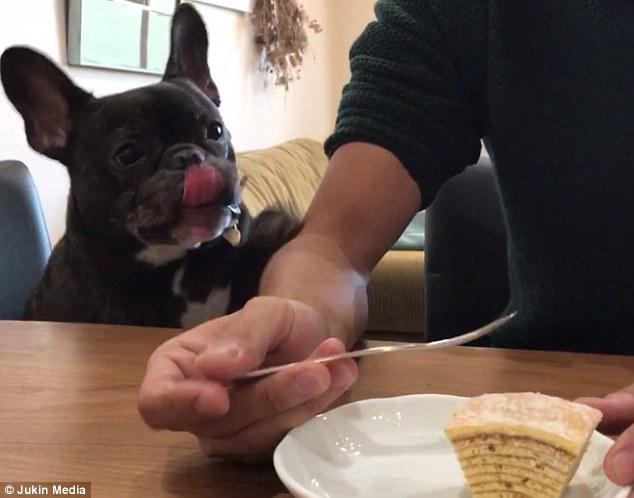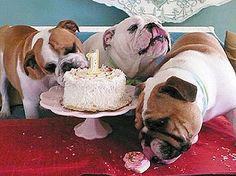The first image is the image on the left, the second image is the image on the right. For the images shown, is this caption "A person is feeding a dog by hand." true? Answer yes or no. No. The first image is the image on the left, the second image is the image on the right. Examine the images to the left and right. Is the description "Each image contains a french bulldog with brindle fur that is eating, or trying to eat, human food." accurate? Answer yes or no. No. 